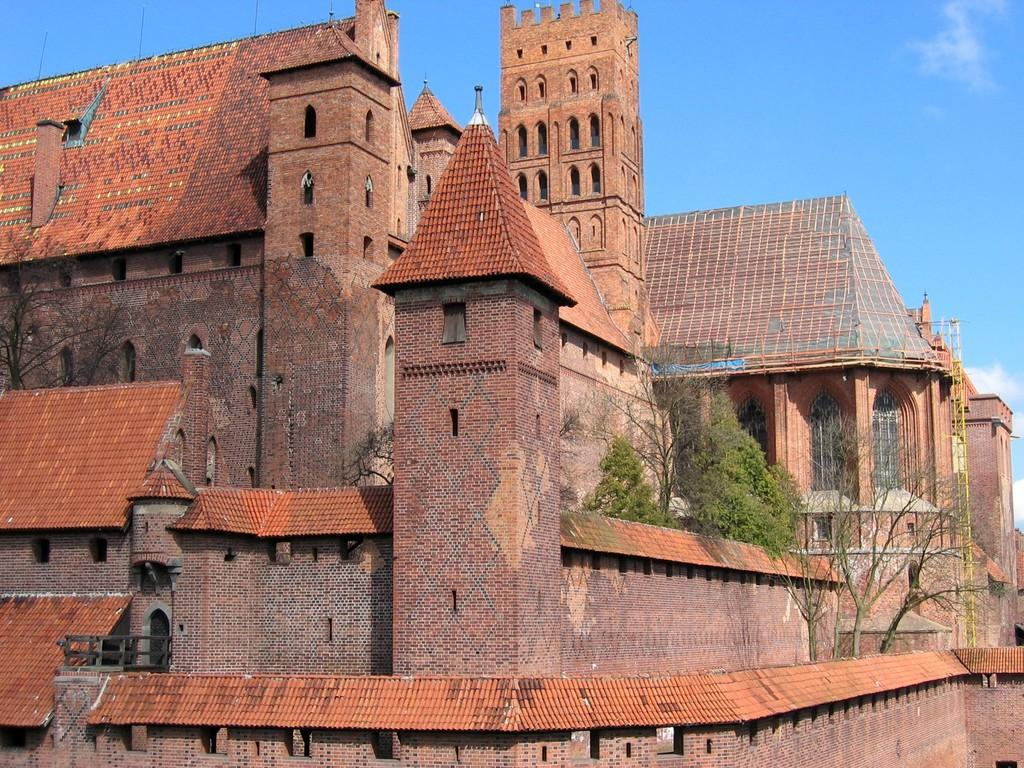What type of structures can be seen in the image? There are buildings in the image. What other elements are present in the image besides buildings? There are trees, windows, and a grille visible in the image. What can be seen in the background of the image? The sky with clouds is visible in the background of the image. What type of board is the bat using to play in the image? There is no bat or board present in the image. 